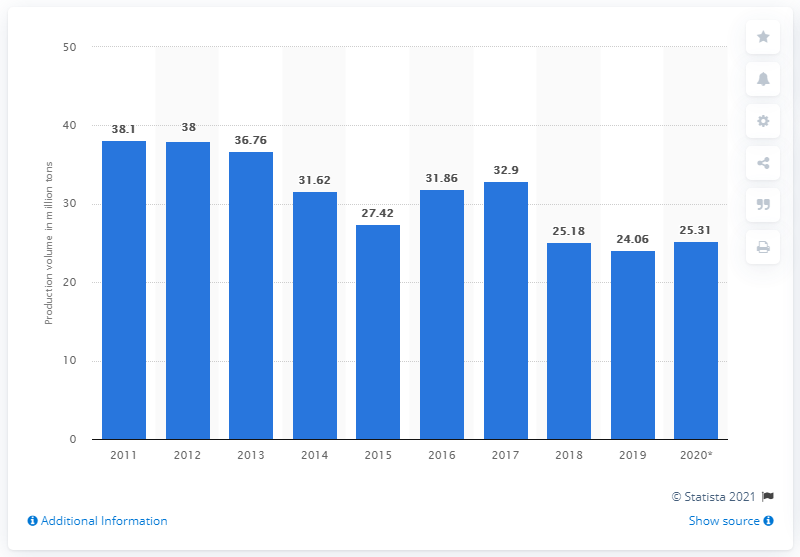Give some essential details in this illustration. The value of the blue bar in 2018 was 25.18. In 2020, the production volume of rice in Thailand was 25.18 million metric tons. In 2018, there was a significant decline in rice production, making it the year with the most adverse change in rice production. In 2019, the production volume of rice in Thailand was approximately 24.06 million metric tons. 